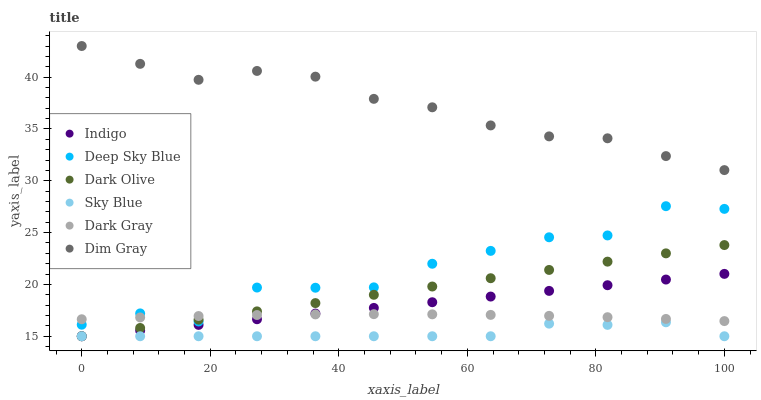Does Sky Blue have the minimum area under the curve?
Answer yes or no. Yes. Does Dim Gray have the maximum area under the curve?
Answer yes or no. Yes. Does Indigo have the minimum area under the curve?
Answer yes or no. No. Does Indigo have the maximum area under the curve?
Answer yes or no. No. Is Dark Olive the smoothest?
Answer yes or no. Yes. Is Deep Sky Blue the roughest?
Answer yes or no. Yes. Is Indigo the smoothest?
Answer yes or no. No. Is Indigo the roughest?
Answer yes or no. No. Does Indigo have the lowest value?
Answer yes or no. Yes. Does Dark Gray have the lowest value?
Answer yes or no. No. Does Dim Gray have the highest value?
Answer yes or no. Yes. Does Indigo have the highest value?
Answer yes or no. No. Is Dark Olive less than Dim Gray?
Answer yes or no. Yes. Is Dim Gray greater than Deep Sky Blue?
Answer yes or no. Yes. Does Indigo intersect Sky Blue?
Answer yes or no. Yes. Is Indigo less than Sky Blue?
Answer yes or no. No. Is Indigo greater than Sky Blue?
Answer yes or no. No. Does Dark Olive intersect Dim Gray?
Answer yes or no. No. 